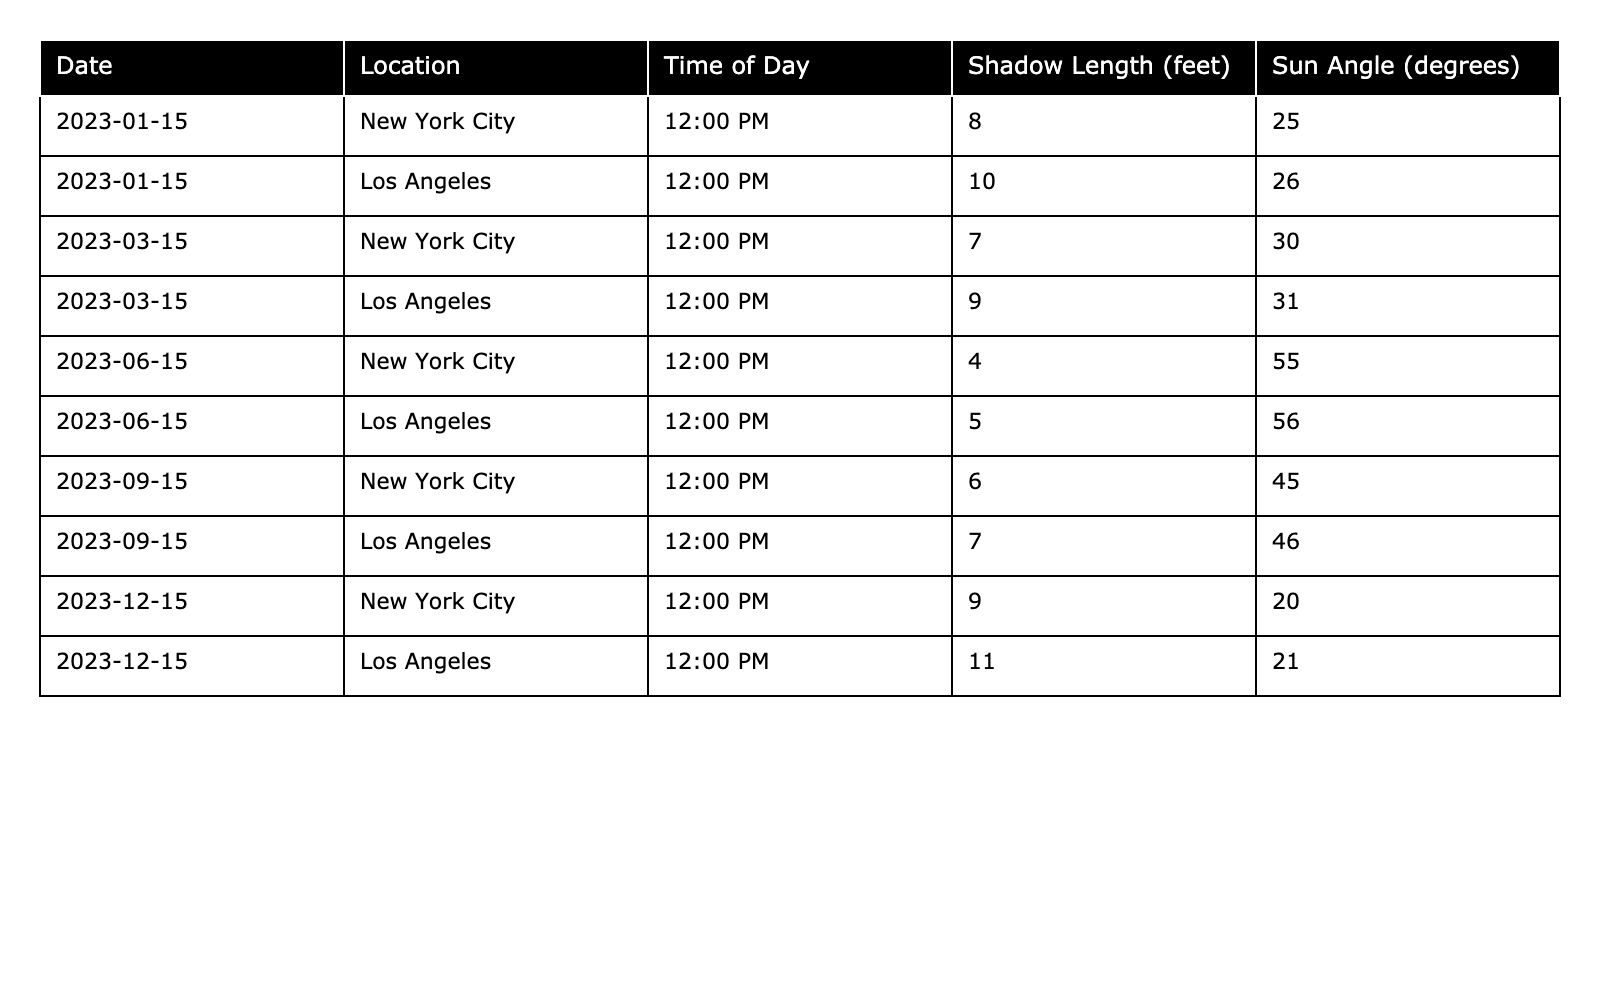What is the shadow length in New York City on March 15, 2023? By referring to the table, locate the entry for New York City under the date March 15, 2023, which shows a shadow length of 7 feet.
Answer: 7 feet What is the shadow length in Los Angeles on December 15, 2023? Check the row for Los Angeles on December 15, 2023 in the table, which indicates that the shadow length is 11 feet.
Answer: 11 feet Which location has the longest shadow on June 15, 2023? Compare the shadow lengths on June 15, 2023: New York City has 4 feet and Los Angeles has 5 feet. Los Angeles has the longest shadow.
Answer: Los Angeles What is the difference in shadow length between New York City and Los Angeles on September 15, 2023? For New York City, the shadow length is 6 feet and for Los Angeles, it is 7 feet. The difference is 7 - 6 = 1 foot.
Answer: 1 foot What is the average shadow length for New York City across all dates? The shadow lengths for New York City are: 8, 7, 4, 6, and 9 feet. Summing these gives 34 feet. There are 5 entries, so the average is 34/5 = 6.8 feet.
Answer: 6.8 feet Is the sun angle on December 15, 2023, higher in Los Angeles than in New York City? Check the table for December 15, 2023: New York City has a sun angle of 20 degrees and Los Angeles has 21 degrees. Since 21 > 20, the sun angle is higher in Los Angeles.
Answer: Yes Which month has the shortest average shadow length for both cities combined? For each month, calculate the average shadow length: January (9), March (8), June (9), September (13), December (20) gives averages of 8, 8, 9, 6.5, and 10. For January, March has the shortest average shadow.
Answer: March What is the total shadow length for all entries in Los Angeles? Sum the shadow lengths for Los Angeles: 10 + 9 + 5 + 7 + 11 = 42 feet. So, the total is 42 feet.
Answer: 42 feet How does the shadow length change from March to June in New York City? In March, the shadow length is 7 feet, and in June, it is 4 feet, showing a decrease of 7 - 4 = 3 feet.
Answer: Decrease of 3 feet Is there a trend indicating that shadow lengths increase or decrease as the year progresses in either city? By examining the data, shadow lengths generally decrease moving from January (8) to June (4) but increase again by December (9); so, there's a pattern of decrease early in the year, followed by rise.
Answer: Yes, it decreases then rises 